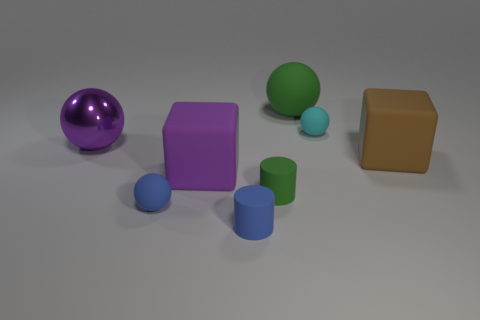Is there another thing that has the same shape as the shiny thing?
Offer a terse response. Yes. What size is the cyan sphere behind the brown thing behind the blue rubber cylinder?
Provide a short and direct response. Small. The small blue object in front of the tiny matte sphere in front of the big purple thing that is to the left of the tiny blue matte sphere is what shape?
Your response must be concise. Cylinder. What is the size of the cyan thing that is made of the same material as the large brown thing?
Your response must be concise. Small. Are there more big purple cubes than red balls?
Make the answer very short. Yes. There is a green thing that is the same size as the brown matte object; what material is it?
Your answer should be very brief. Rubber. There is a green thing that is behind the cyan thing; is it the same size as the purple matte thing?
Offer a very short reply. Yes. What number of cylinders are either purple objects or large purple metal things?
Give a very brief answer. 0. There is a big block that is left of the large green rubber thing; what is its material?
Your answer should be very brief. Rubber. Are there fewer big brown matte objects than yellow shiny balls?
Keep it short and to the point. No. 